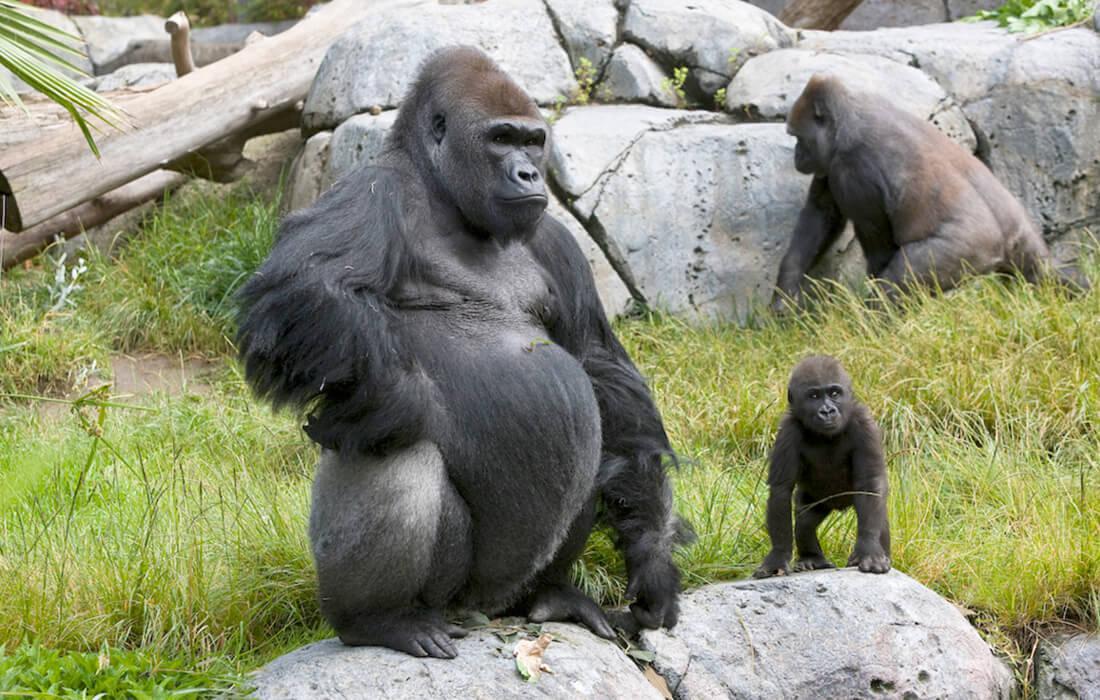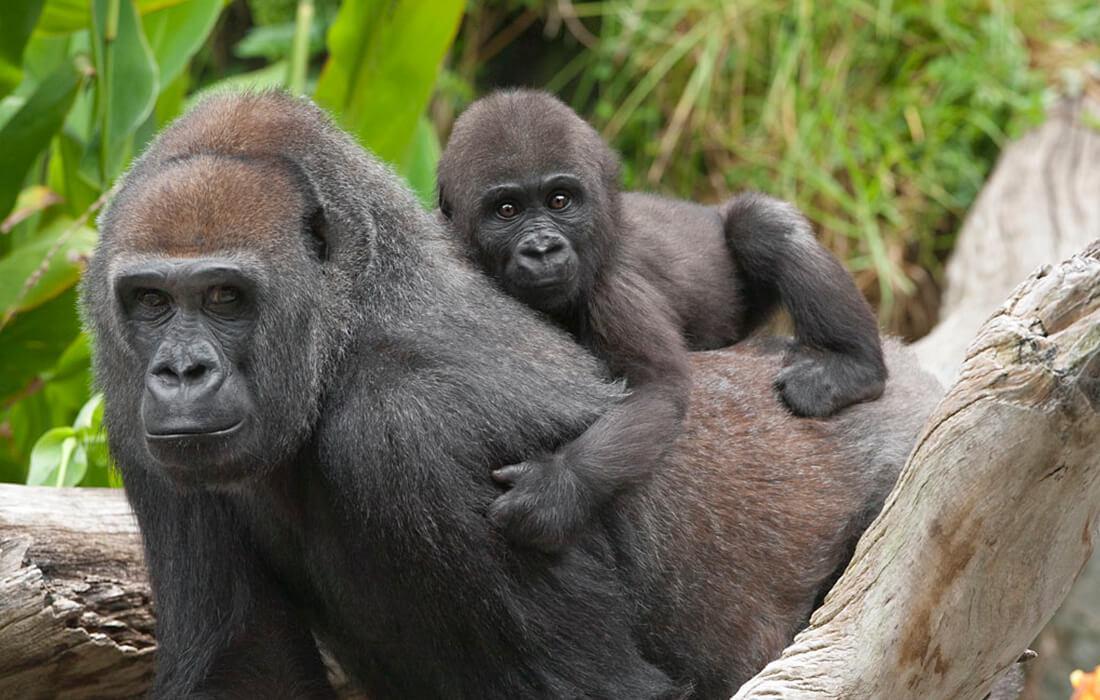The first image is the image on the left, the second image is the image on the right. Analyze the images presented: Is the assertion "One image shows exactly three gorillas, including a baby." valid? Answer yes or no. Yes. The first image is the image on the left, the second image is the image on the right. Considering the images on both sides, is "An image shows three gorillas of different sizes." valid? Answer yes or no. Yes. The first image is the image on the left, the second image is the image on the right. Considering the images on both sides, is "There is exactly one animal in the image on the left." valid? Answer yes or no. No. 